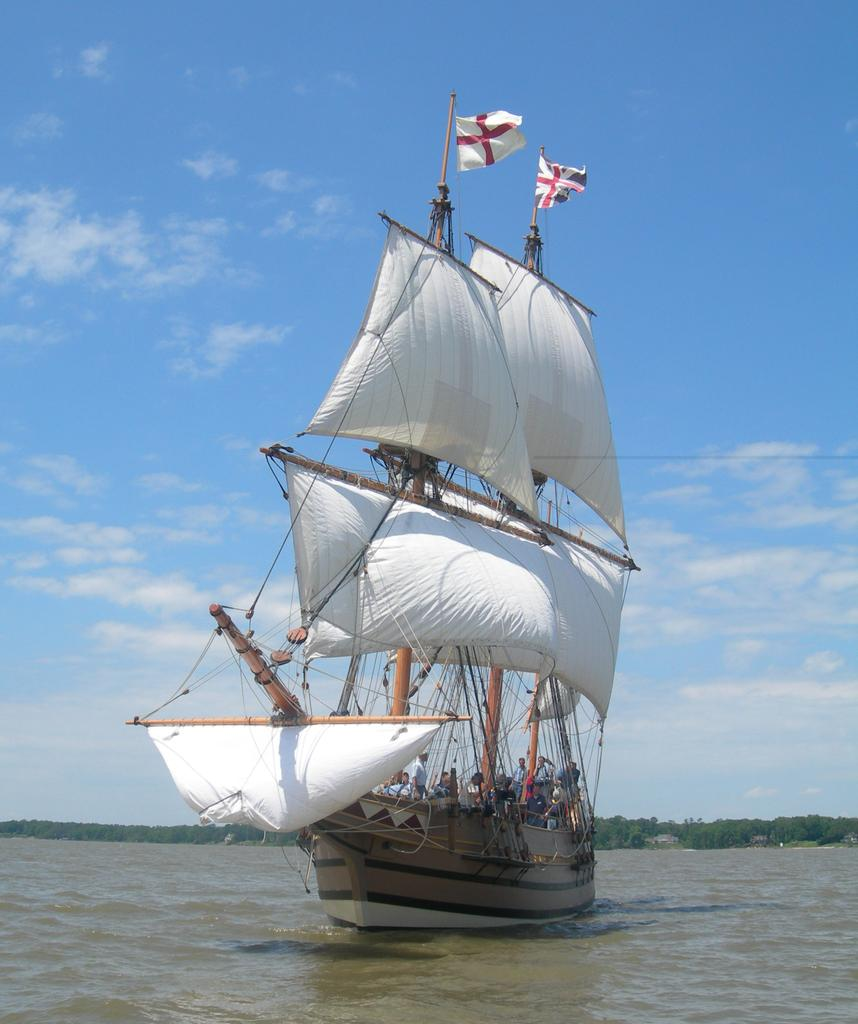What activity are the people in the image engaged in? The people in the image are sailing a boat. Where is the boat located? The boat is on the water. What objects can be seen in the image related to the boat? There are poles, ropes, and flags in the image related to the boat. What can be seen in the background of the image? There are trees and the sky visible in the background of the image. How does the beginner sailor handle the destruction of the boat in the image? There is no destruction of the boat in the image, and no indication of a beginner sailor. 